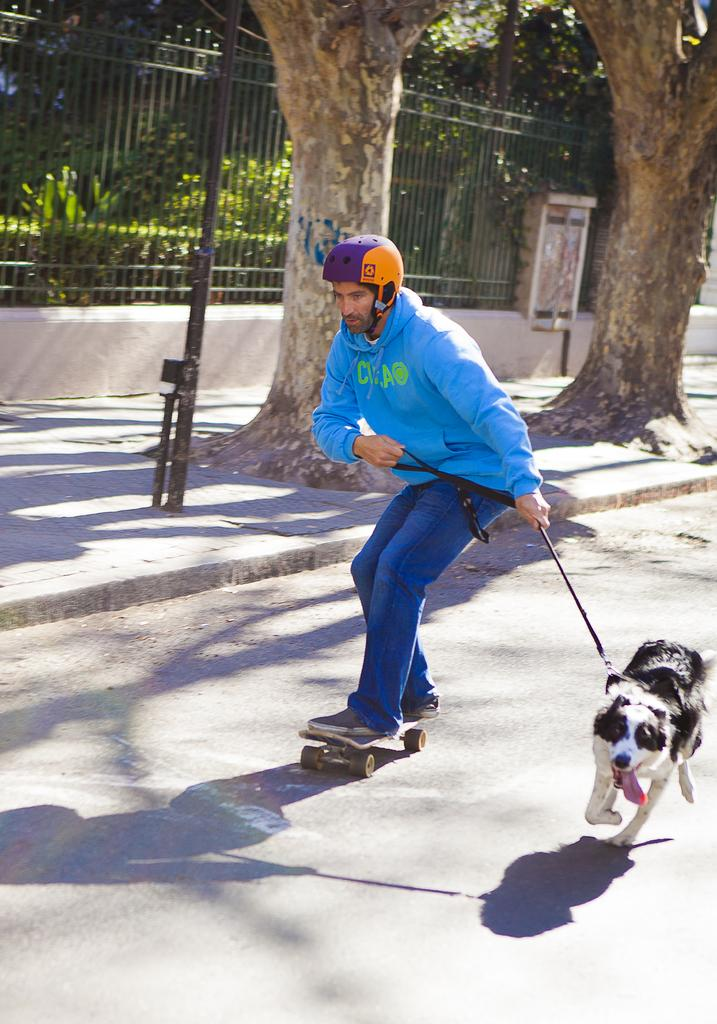What is the man in the image doing? The man is skating on the road. What is the man holding while skating? The man is holding a belt. What can be seen at the bottom of the image? There is a road and a dog visible at the bottom of the image. What is visible in the background of the image? There are trees, a pole, and a fence visible in the background of the image. How many toes can be seen on the man's feet in the image? The image does not show the man's toes, so it is not possible to determine the number of toes. 